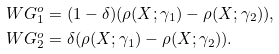Convert formula to latex. <formula><loc_0><loc_0><loc_500><loc_500>W G _ { 1 } ^ { o } & = ( 1 - \delta ) ( \rho ( X ; \gamma _ { 1 } ) - \rho ( X ; \gamma _ { 2 } ) ) , \\ W G _ { 2 } ^ { o } & = \delta ( \rho ( X ; \gamma _ { 1 } ) - \rho ( X ; \gamma _ { 2 } ) ) .</formula> 